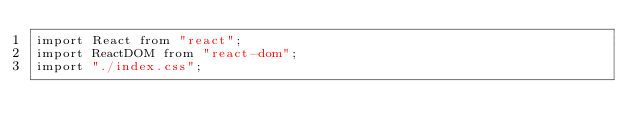<code> <loc_0><loc_0><loc_500><loc_500><_TypeScript_>import React from "react";
import ReactDOM from "react-dom";
import "./index.css";</code> 